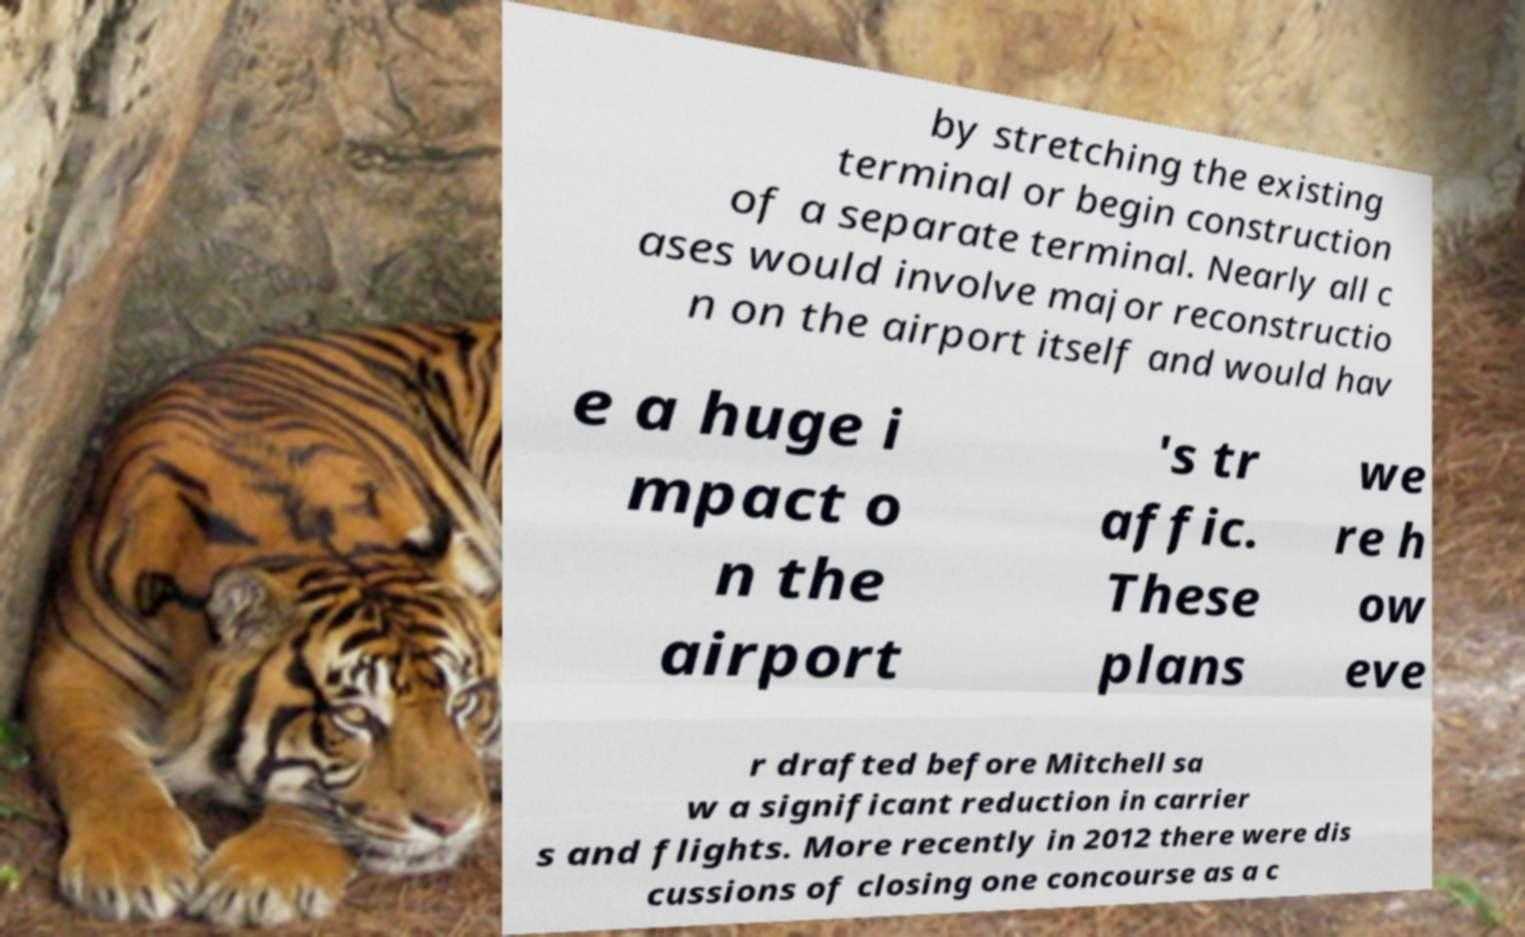What messages or text are displayed in this image? I need them in a readable, typed format. by stretching the existing terminal or begin construction of a separate terminal. Nearly all c ases would involve major reconstructio n on the airport itself and would hav e a huge i mpact o n the airport 's tr affic. These plans we re h ow eve r drafted before Mitchell sa w a significant reduction in carrier s and flights. More recently in 2012 there were dis cussions of closing one concourse as a c 